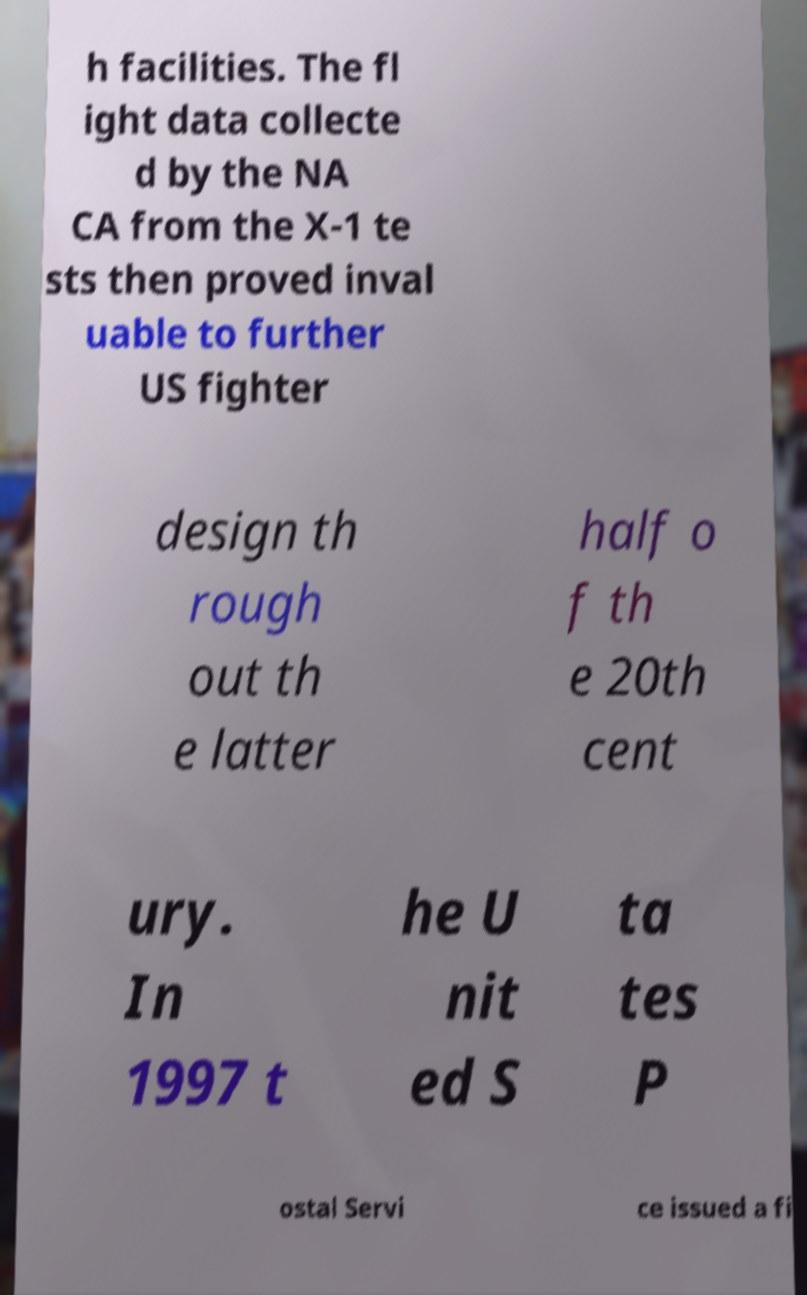I need the written content from this picture converted into text. Can you do that? h facilities. The fl ight data collecte d by the NA CA from the X-1 te sts then proved inval uable to further US fighter design th rough out th e latter half o f th e 20th cent ury. In 1997 t he U nit ed S ta tes P ostal Servi ce issued a fi 